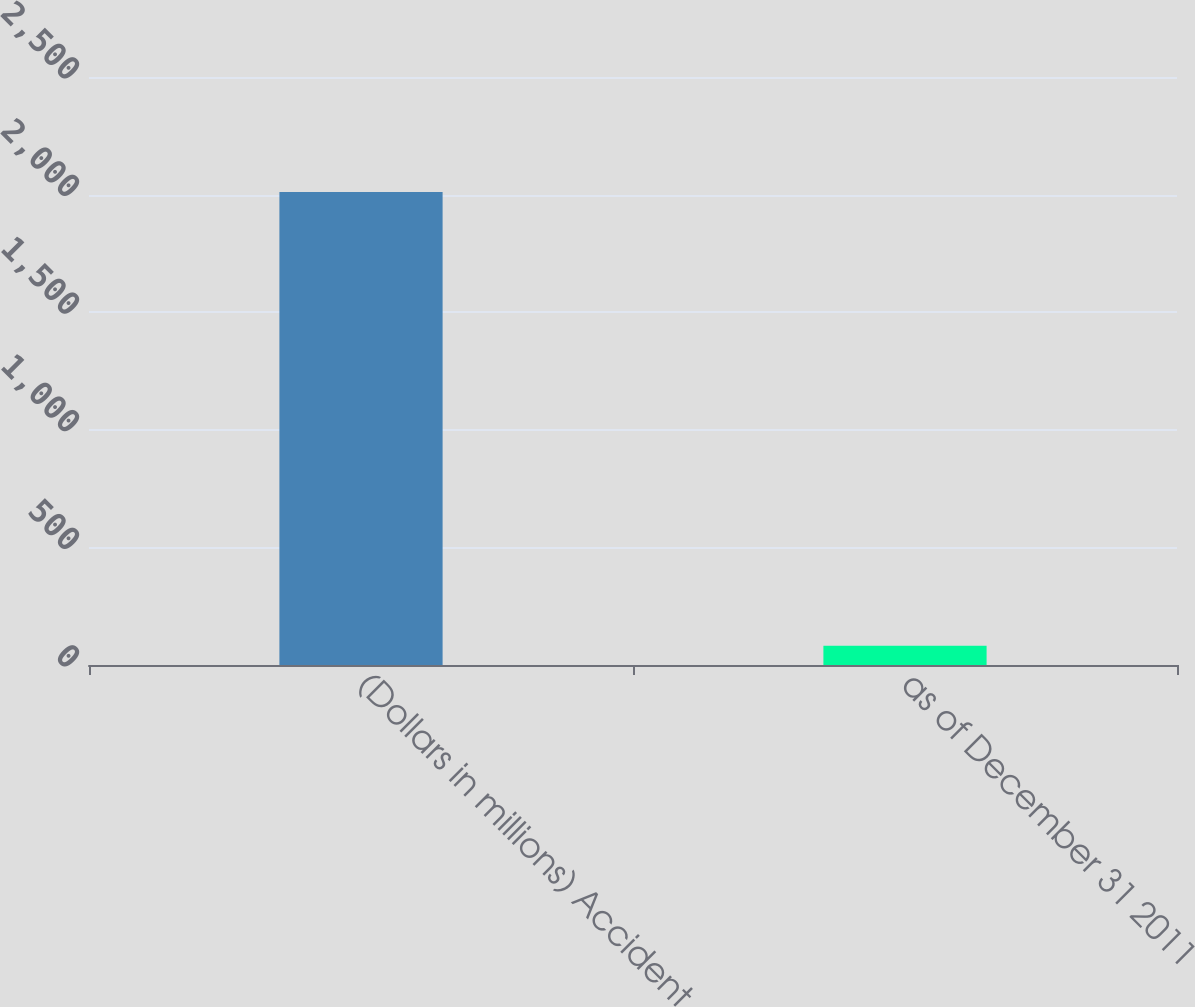<chart> <loc_0><loc_0><loc_500><loc_500><bar_chart><fcel>(Dollars in millions) Accident<fcel>as of December 31 2011<nl><fcel>2011<fcel>82.1<nl></chart> 